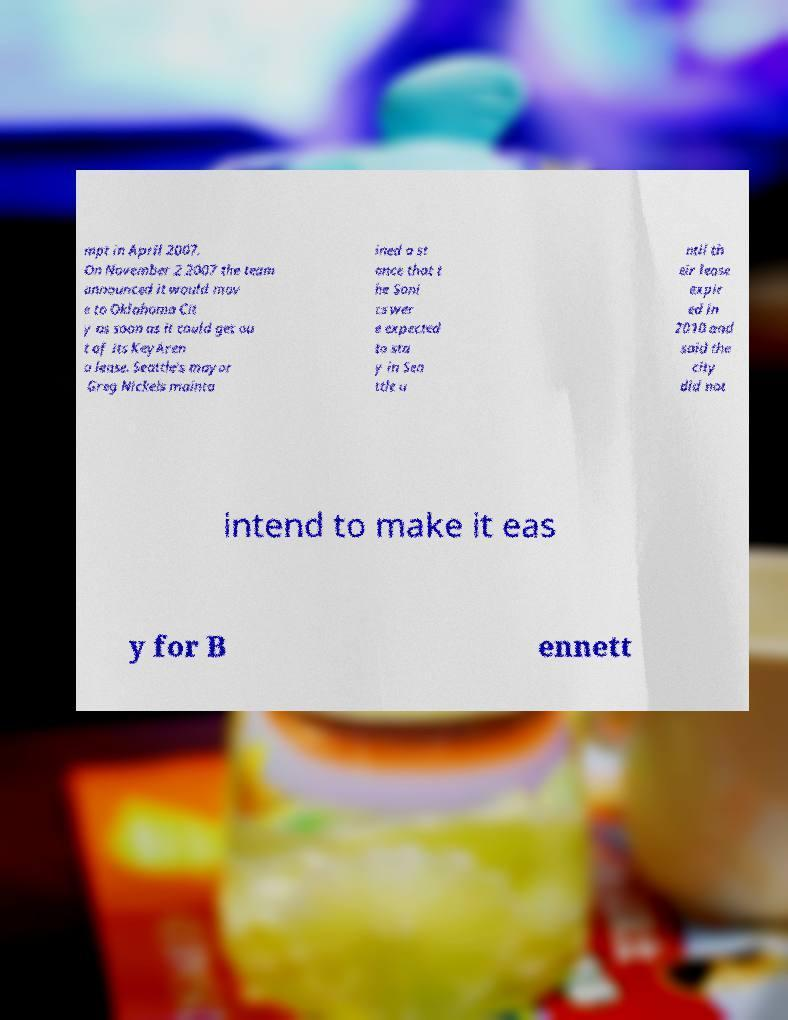I need the written content from this picture converted into text. Can you do that? mpt in April 2007. On November 2 2007 the team announced it would mov e to Oklahoma Cit y as soon as it could get ou t of its KeyAren a lease. Seattle's mayor Greg Nickels mainta ined a st ance that t he Soni cs wer e expected to sta y in Sea ttle u ntil th eir lease expir ed in 2010 and said the city did not intend to make it eas y for B ennett 